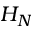Convert formula to latex. <formula><loc_0><loc_0><loc_500><loc_500>H _ { N }</formula> 